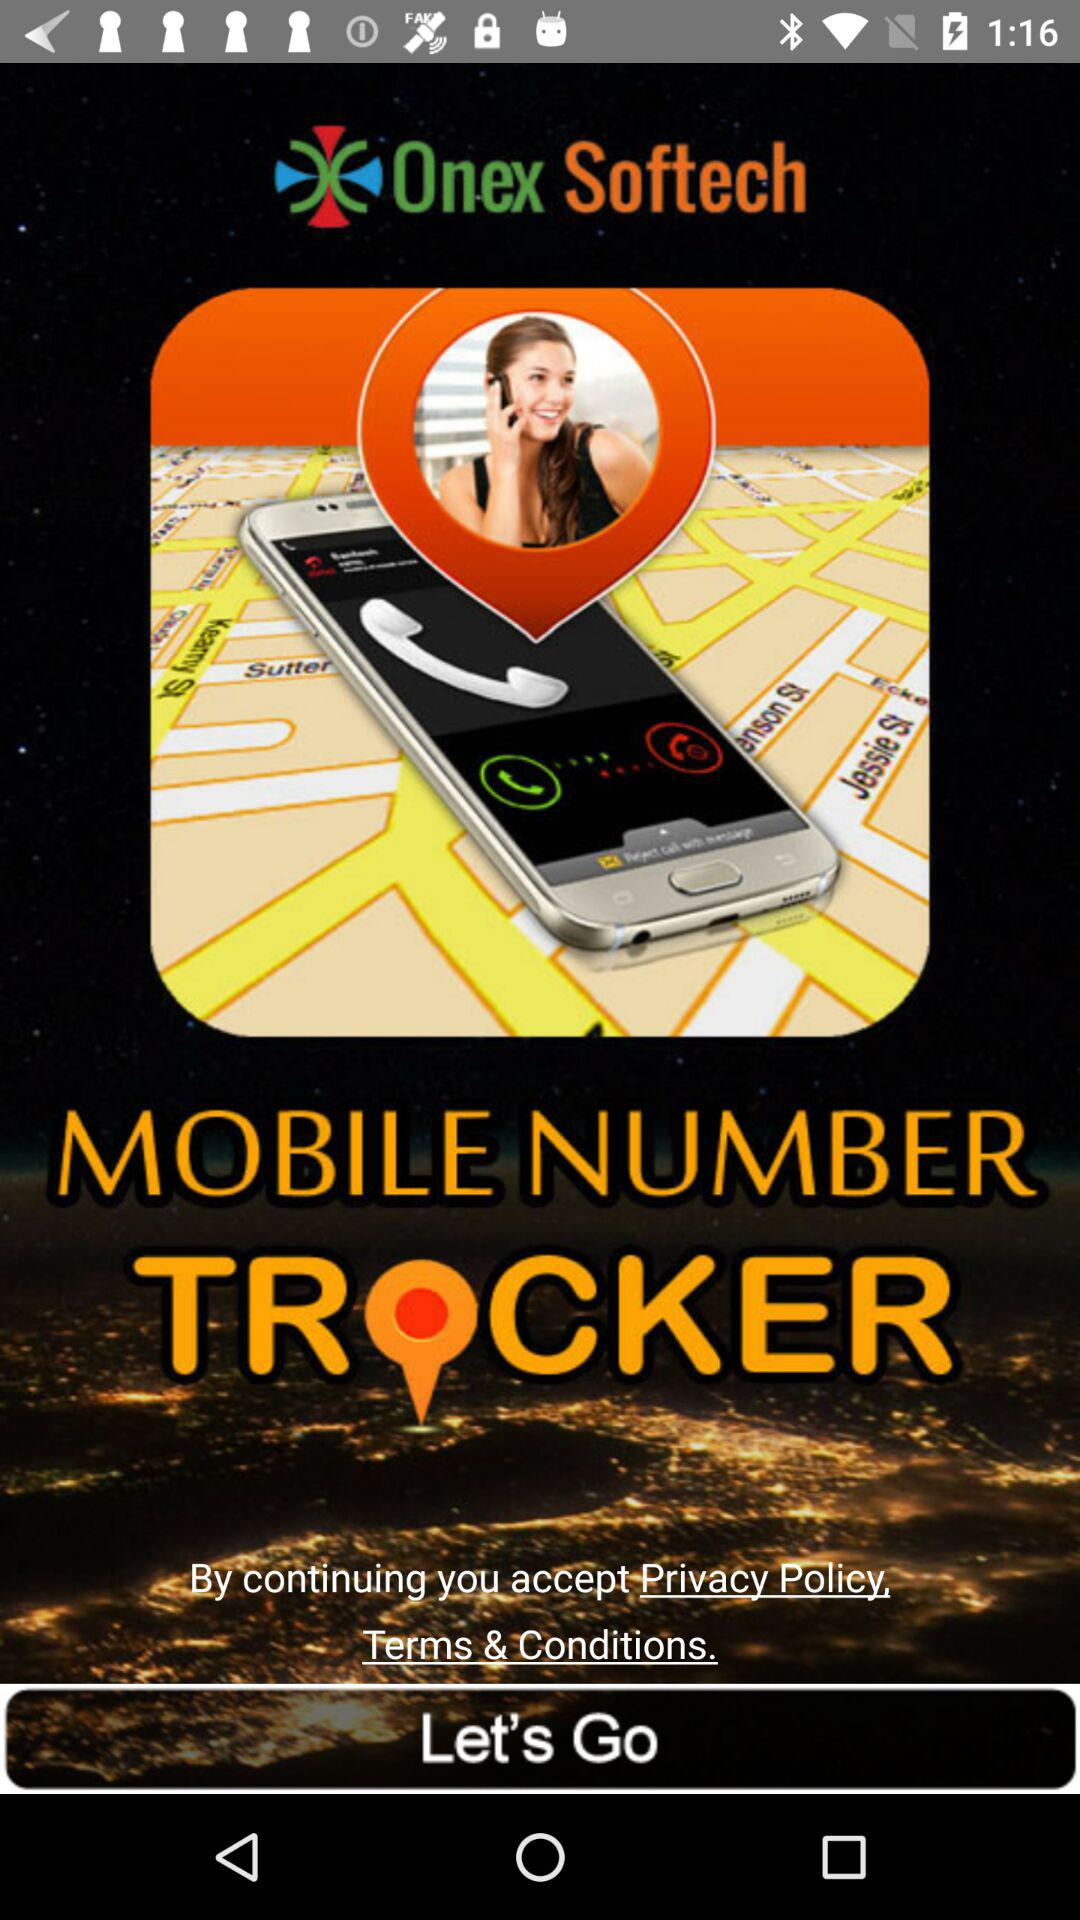What is the application name? The application name is "Onex Softech". 